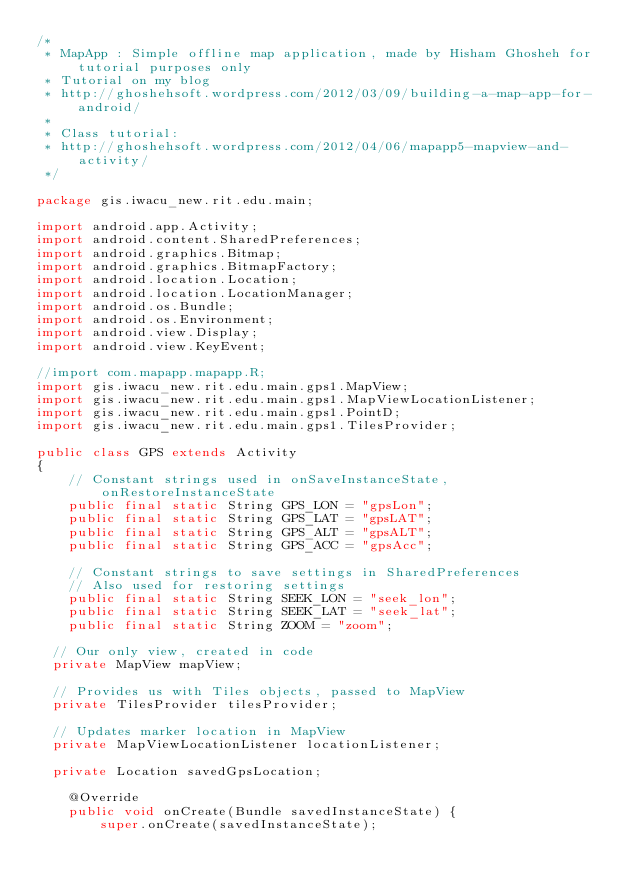Convert code to text. <code><loc_0><loc_0><loc_500><loc_500><_Java_>/*
 * MapApp : Simple offline map application, made by Hisham Ghosheh for tutorial purposes only
 * Tutorial on my blog
 * http://ghoshehsoft.wordpress.com/2012/03/09/building-a-map-app-for-android/
 * 
 * Class tutorial:
 * http://ghoshehsoft.wordpress.com/2012/04/06/mapapp5-mapview-and-activity/
 */

package gis.iwacu_new.rit.edu.main;

import android.app.Activity;
import android.content.SharedPreferences;
import android.graphics.Bitmap;
import android.graphics.BitmapFactory;
import android.location.Location;
import android.location.LocationManager;
import android.os.Bundle;
import android.os.Environment;
import android.view.Display;
import android.view.KeyEvent;

//import com.mapapp.mapapp.R;
import gis.iwacu_new.rit.edu.main.gps1.MapView;
import gis.iwacu_new.rit.edu.main.gps1.MapViewLocationListener;
import gis.iwacu_new.rit.edu.main.gps1.PointD;
import gis.iwacu_new.rit.edu.main.gps1.TilesProvider;

public class GPS extends Activity
{
    // Constant strings used in onSaveInstanceState, onRestoreInstanceState
    public final static String GPS_LON = "gpsLon";
    public final static String GPS_LAT = "gpsLAT";
    public final static String GPS_ALT = "gpsALT";
    public final static String GPS_ACC = "gpsAcc";

    // Constant strings to save settings in SharedPreferences
    // Also used for restoring settings
    public final static String SEEK_LON = "seek_lon";
    public final static String SEEK_LAT = "seek_lat";
    public final static String ZOOM = "zoom";

	// Our only view, created in code
	private MapView mapView;

	// Provides us with Tiles objects, passed to MapView
	private TilesProvider tilesProvider;

	// Updates marker location in MapView
	private MapViewLocationListener locationListener;

	private Location savedGpsLocation;

    @Override
    public void onCreate(Bundle savedInstanceState) {
        super.onCreate(savedInstanceState);
</code> 